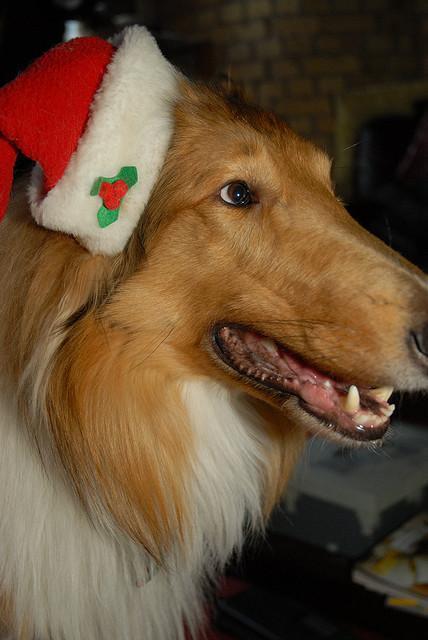How many train tracks can be seen?
Give a very brief answer. 0. 